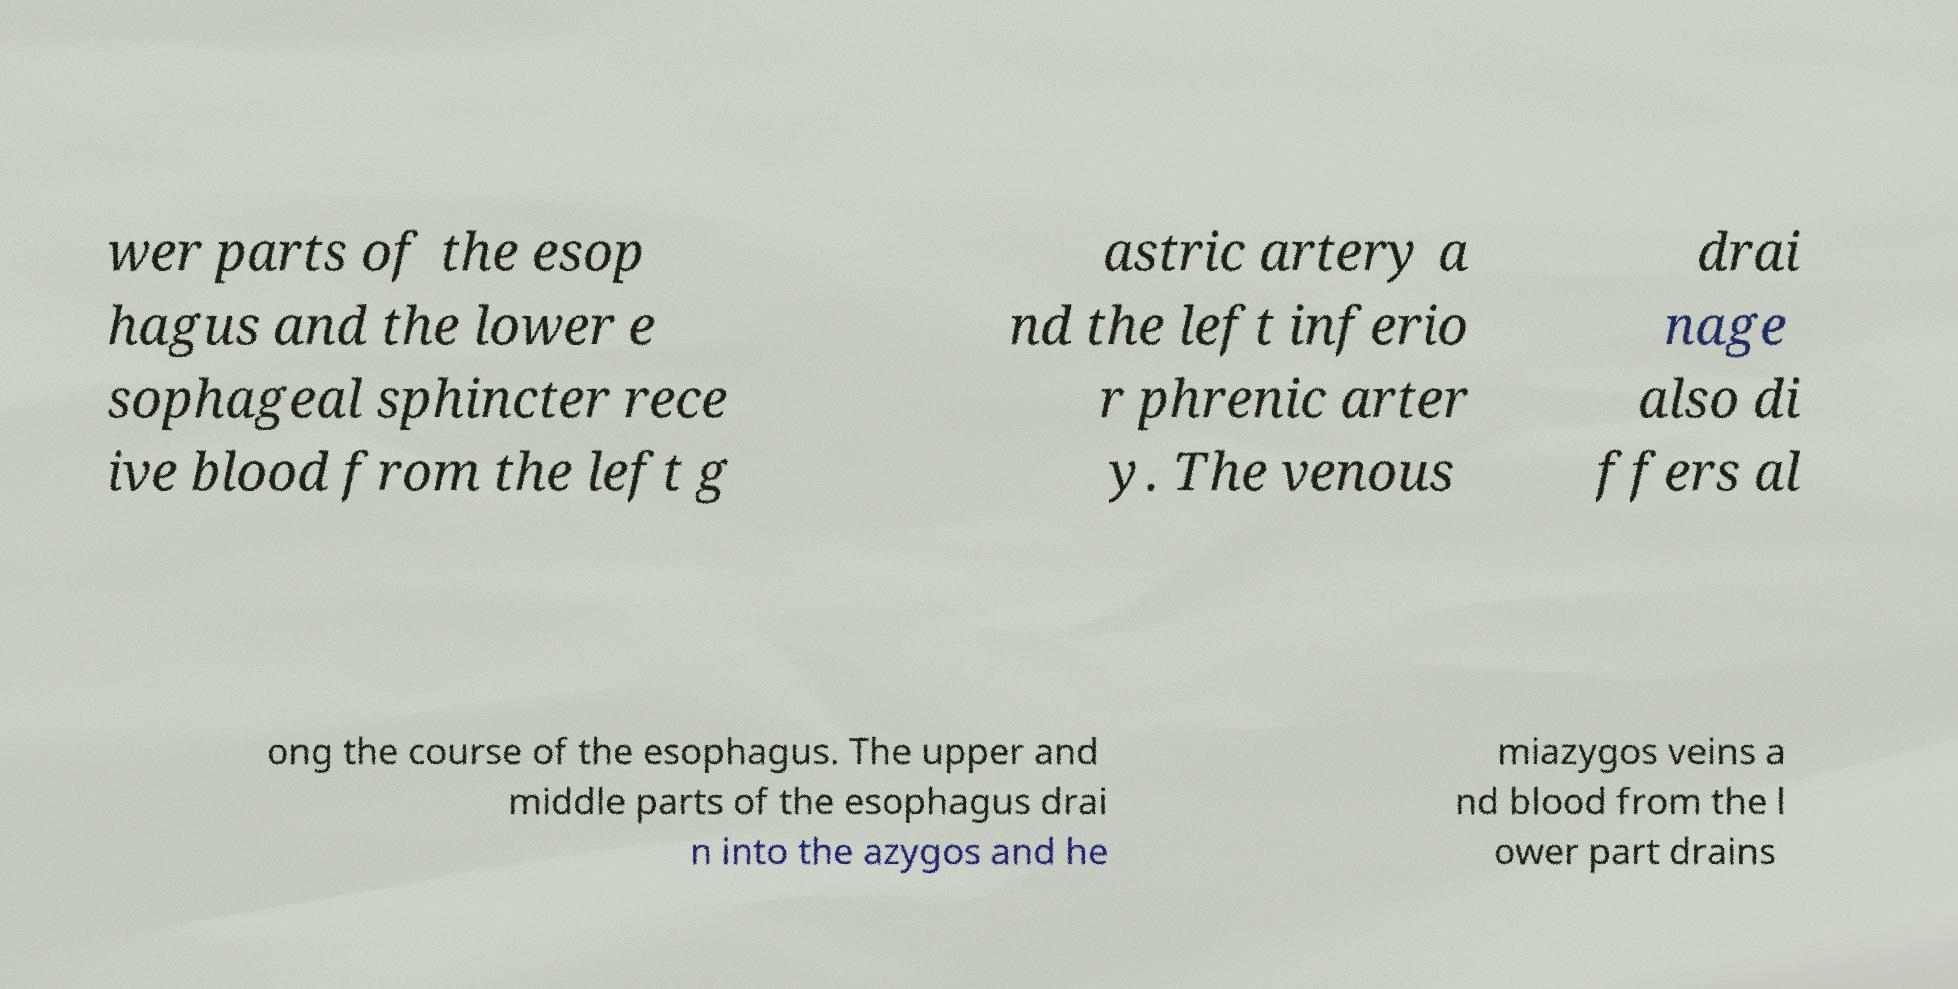Could you assist in decoding the text presented in this image and type it out clearly? wer parts of the esop hagus and the lower e sophageal sphincter rece ive blood from the left g astric artery a nd the left inferio r phrenic arter y. The venous drai nage also di ffers al ong the course of the esophagus. The upper and middle parts of the esophagus drai n into the azygos and he miazygos veins a nd blood from the l ower part drains 